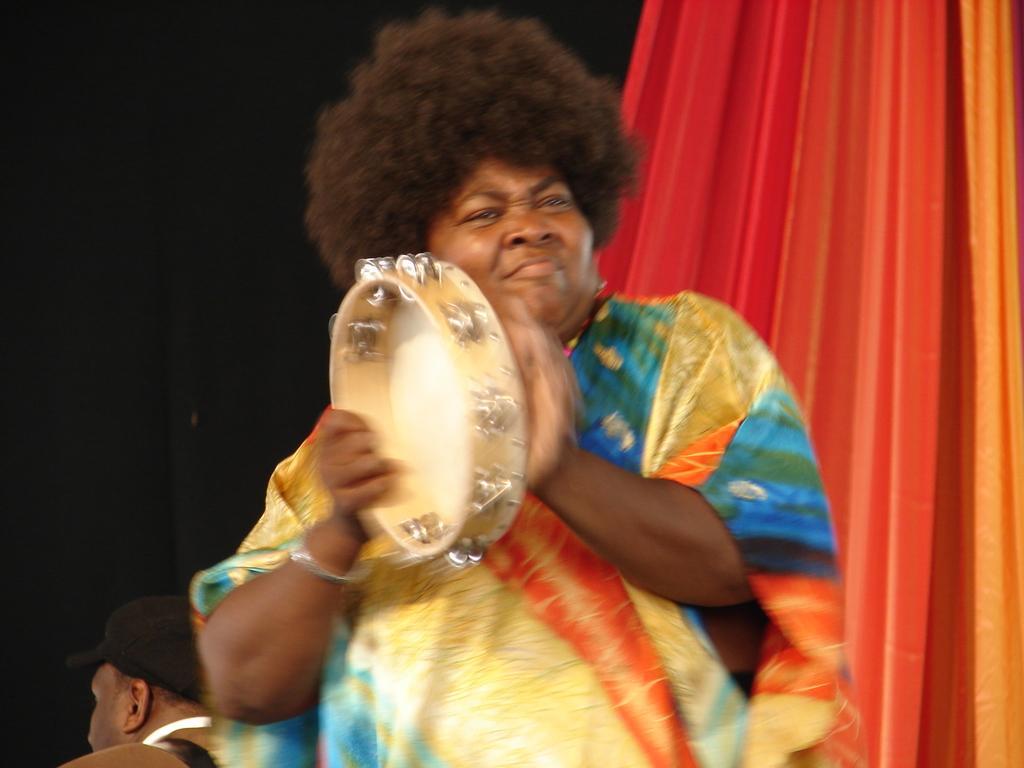Please provide a concise description of this image. In this image, we can see a person is holding a musical instrument. On the right side, we can see curtain. Left side bottom of the image, we can see a person is wearing a cap. Here we can see black color object. 